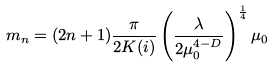<formula> <loc_0><loc_0><loc_500><loc_500>m _ { n } = ( 2 n + 1 ) \frac { \pi } { 2 K ( i ) } \left ( \frac { \lambda } { 2 \mu _ { 0 } ^ { 4 - D } } \right ) ^ { \frac { 1 } { 4 } } \mu _ { 0 }</formula> 